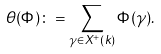<formula> <loc_0><loc_0><loc_500><loc_500>\theta ( \Phi ) \colon = \sum _ { \gamma \in X ^ { + } ( k ) } \Phi ( \gamma ) .</formula> 